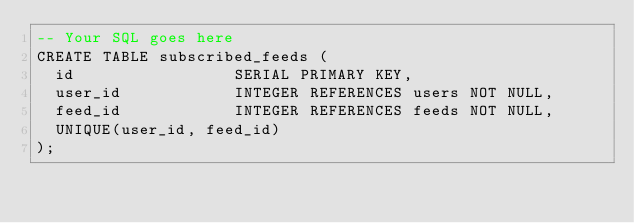Convert code to text. <code><loc_0><loc_0><loc_500><loc_500><_SQL_>-- Your SQL goes here
CREATE TABLE subscribed_feeds (
  id                 SERIAL PRIMARY KEY,
  user_id            INTEGER REFERENCES users NOT NULL,
  feed_id            INTEGER REFERENCES feeds NOT NULL,
  UNIQUE(user_id, feed_id)
);

</code> 